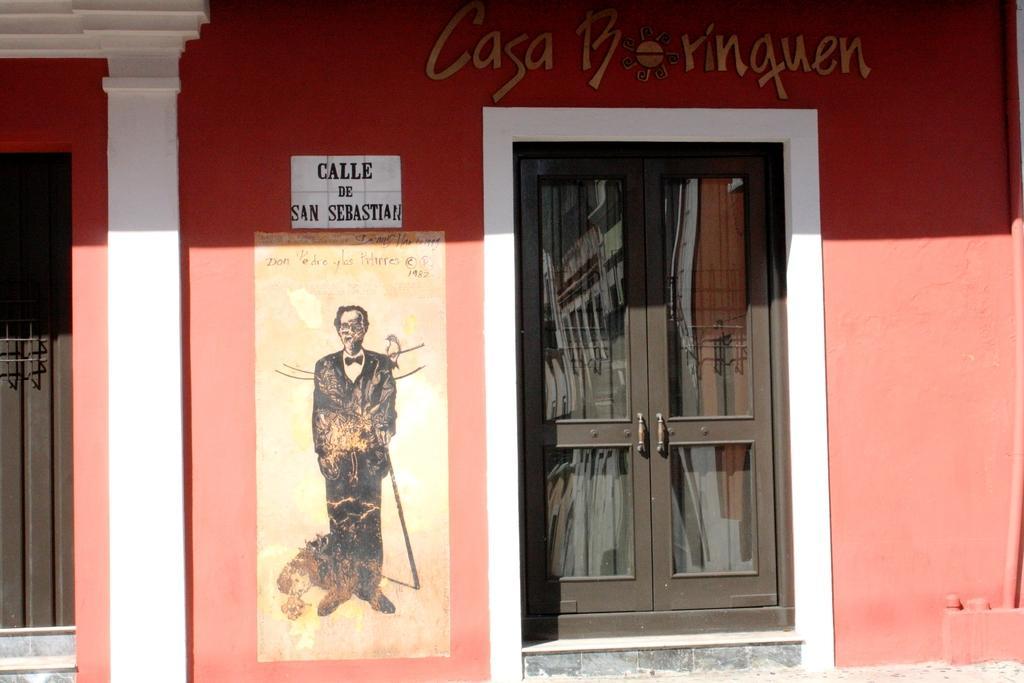Describe this image in one or two sentences. In this picture we can see a poster and a painting on the wall, beside the poster we can see doors, at the top of the image we can find some text on the wall. 